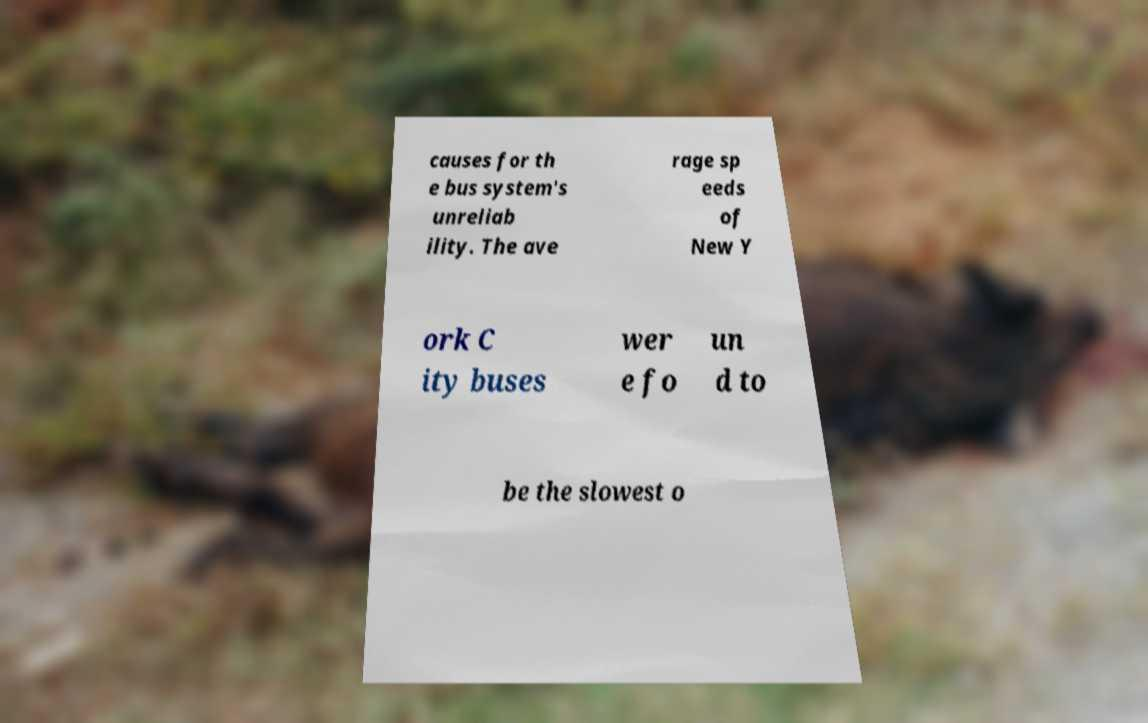There's text embedded in this image that I need extracted. Can you transcribe it verbatim? causes for th e bus system's unreliab ility. The ave rage sp eeds of New Y ork C ity buses wer e fo un d to be the slowest o 